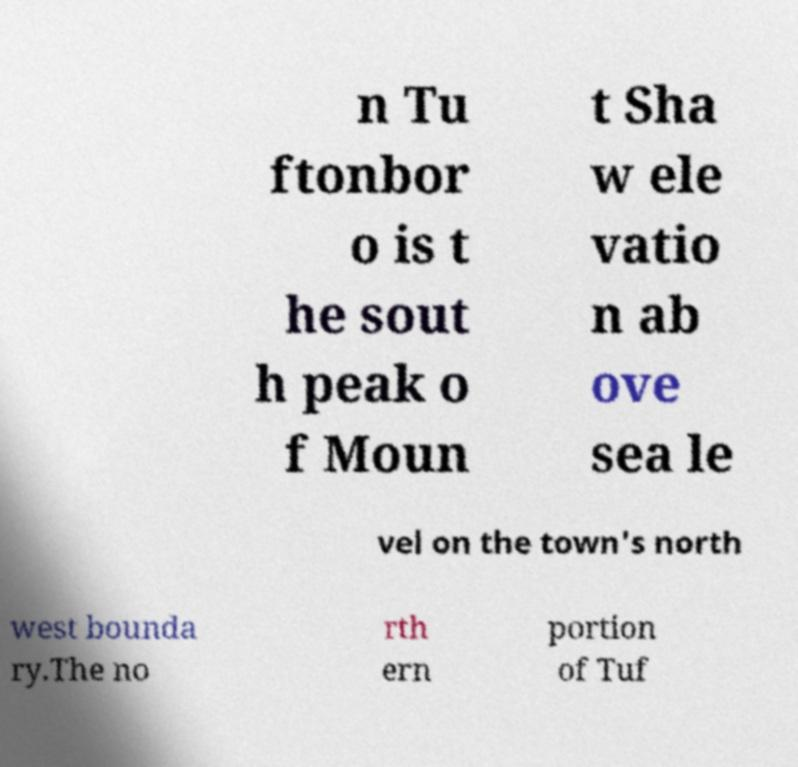I need the written content from this picture converted into text. Can you do that? n Tu ftonbor o is t he sout h peak o f Moun t Sha w ele vatio n ab ove sea le vel on the town's north west bounda ry.The no rth ern portion of Tuf 